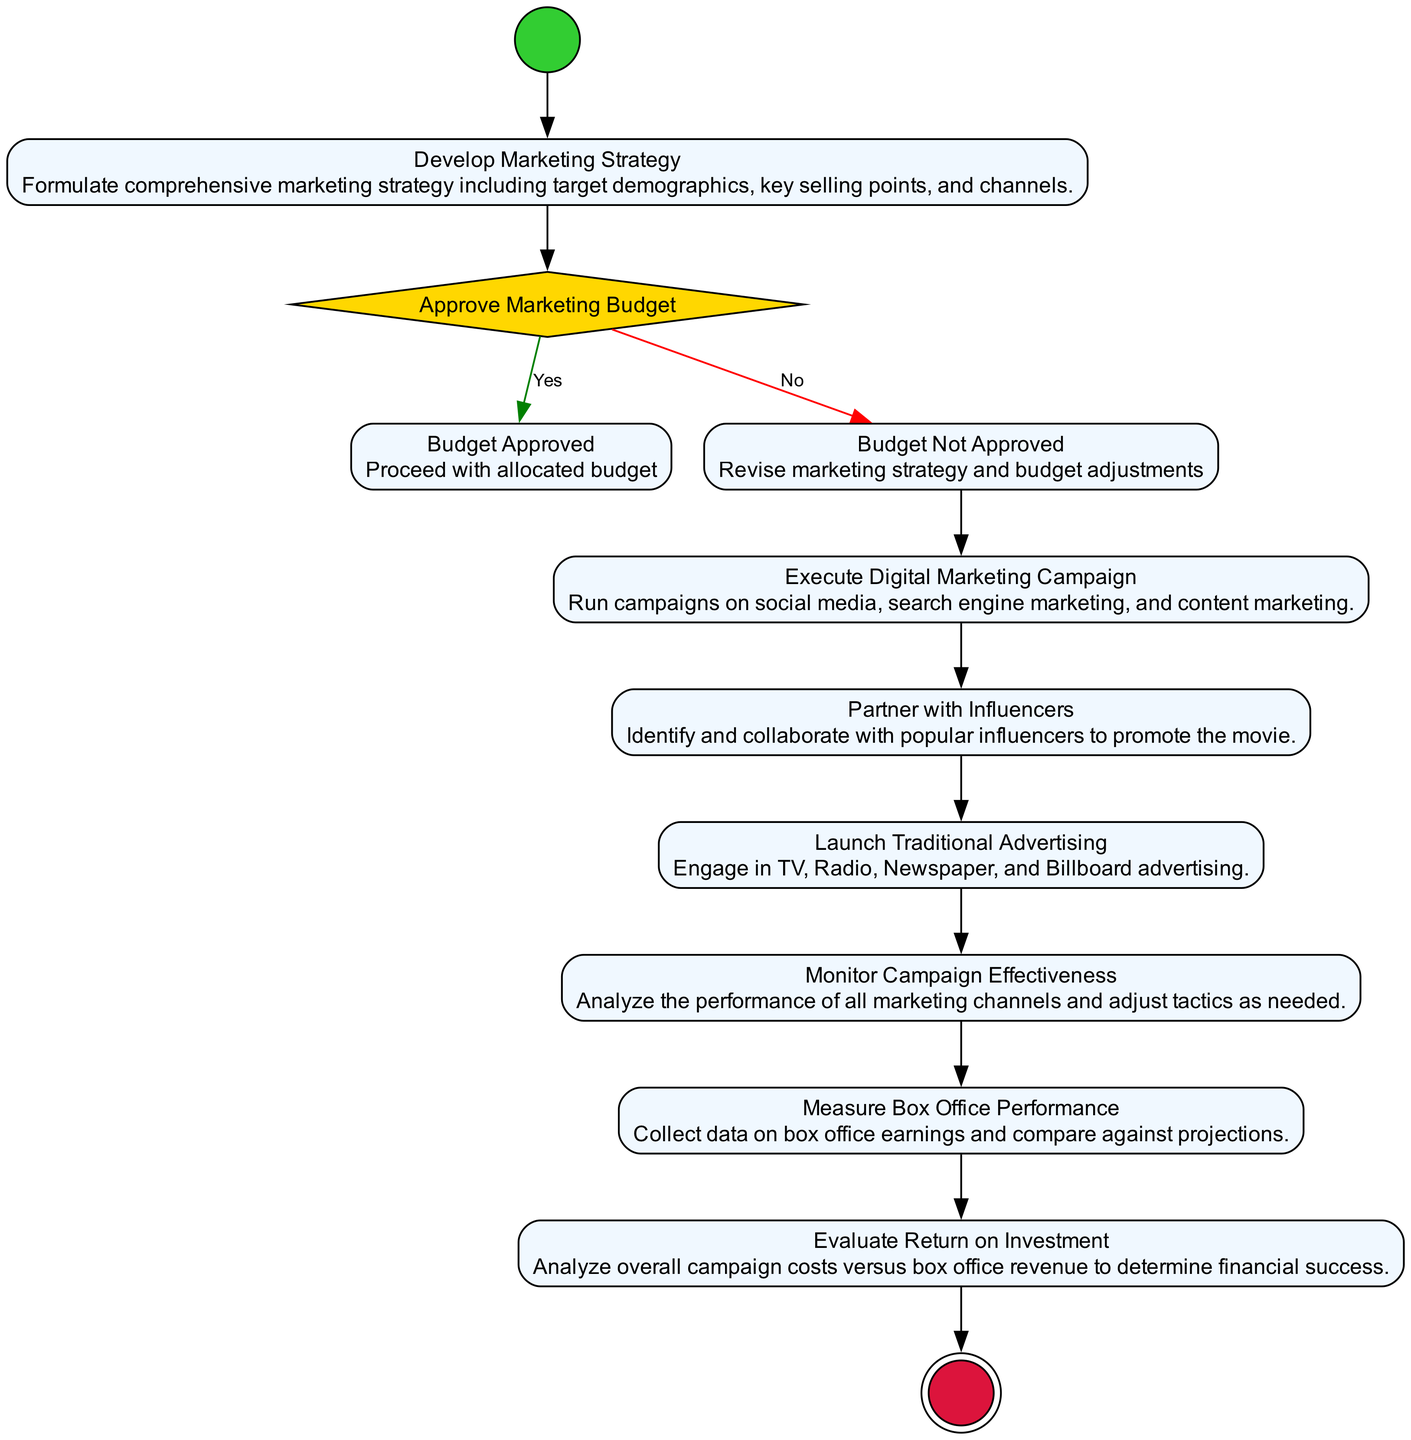What is the first activity in the diagram? The first activity in the diagram is the "Develop Marketing Strategy" which follows the initial node labeled as "Start." Therefore, the first operational step after the initial point is to develop the marketing strategy.
Answer: Develop Marketing Strategy How many activities are shown in the diagram? The diagram includes a total of six distinct activities: "Develop Marketing Strategy," "Budget Approved," "Budget Not Approved," "Execute Digital Marketing Campaign," "Partner with Influencers," "Launch Traditional Advertising," "Monitor Campaign Effectiveness," "Measure Box Office Performance," and "Evaluate Return on Investment." Counting all these activities gives a total of eight.
Answer: Eight What happens if the "Approve Marketing Budget" decision is 'No'? If the "Approve Marketing Budget" decision is 'No', the flow proceeds to the "Budget Not Approved" activity where the marketing strategy and budget adjustments are revised. This path signifies that the marketing budget needs to be reconsidered before further execution of the campaign.
Answer: Revise marketing strategy and budget adjustments Which node evaluates the box office performance? The node that evaluates box office performance is "Measure Box Office Performance." This activity is focused on assessing the earnings from box office returns to gauge how well the film is performing financially.
Answer: Measure Box Office Performance After "Execute Digital Marketing Campaign," what is the next step? The next step after "Execute Digital Marketing Campaign" is "Partner with Influencers." This signifies that after executing the digital marketing efforts, efforts will continue with influencer partnerships to further promote the movie.
Answer: Partner with Influencers How many decision points are represented in the diagram? There is one decision point represented in the diagram, which is the "Approve Marketing Budget." This decision point branches into two outcomes: 'Yes' for Budget Approved and 'No' for Budget Not Approved.
Answer: One What is the final activity in the flow? The final activity in the flow is "Evaluate Return on Investment." This node signifies the last step of assessing the financial impacts of the marketing campaign relative to box office revenue before reaching the end of the process.
Answer: Evaluate Return on Investment What do we do after measuring box office performance? After measuring box office performance, the next action is to "Evaluate Return on Investment," where costs from the marketing campaign are compared against the revenue collected from box office sales to determine the financial outcome of the campaign.
Answer: Evaluate Return on Investment 